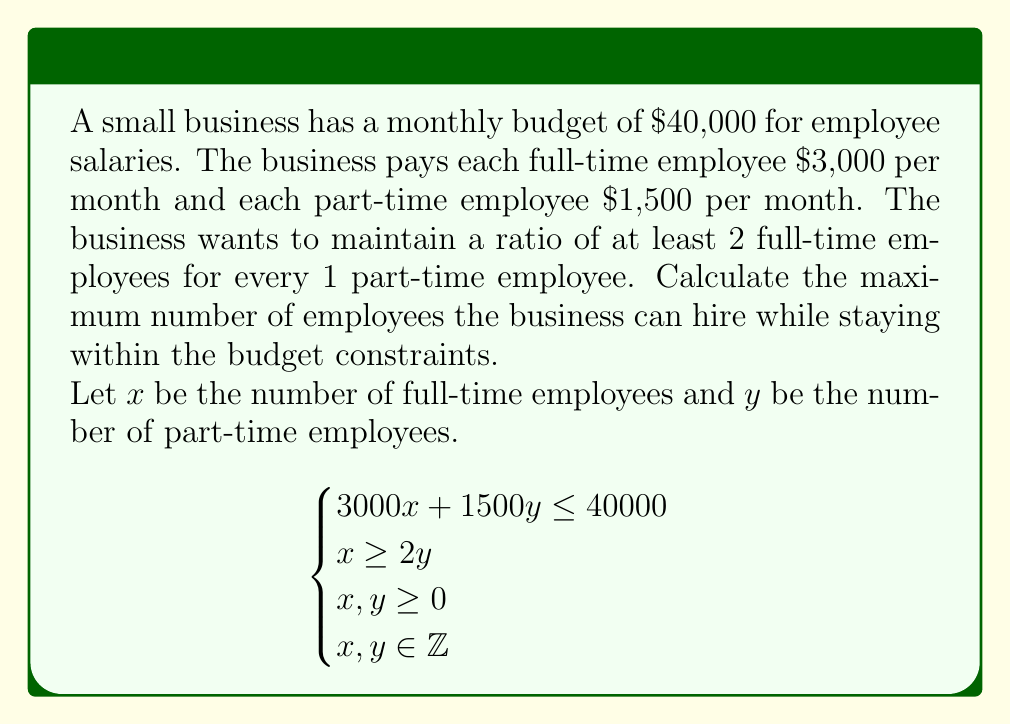Teach me how to tackle this problem. 1. Set up the inequality system:
   $$\begin{cases}
   3000x + 1500y \leq 40000 \quad \text{(budget constraint)} \\
   x \geq 2y \quad \text{(ratio constraint)} \\
   x, y \geq 0 \quad \text{(non-negative constraint)} \\
   x, y \in \mathbb{Z} \quad \text{(integer constraint)}
   \end{cases}$$

2. Simplify the budget constraint:
   $$2x + y \leq \frac{80}{3}$$

3. The objective is to maximize $x + y$ (total number of employees).

4. From the ratio constraint, we can substitute $x = 2y + z$, where $z \geq 0$.

5. Substituting into the budget constraint:
   $$2(2y + z) + y \leq \frac{80}{3}$$
   $$4y + 2z + y \leq \frac{80}{3}$$
   $$5y + 2z \leq \frac{80}{3}$$

6. To maximize $x + y = (2y + z) + y = 3y + z$, we should set $z = 0$.

7. With $z = 0$, we have:
   $$5y \leq \frac{80}{3}$$
   $$y \leq \frac{16}{3}$$

8. The maximum integer value for $y$ is 5.

9. With $y = 5$, we can calculate $x$:
   $$x = 2y = 2(5) = 10$$

10. Therefore, the maximum number of employees is $x + y = 10 + 5 = 15$.
Answer: 15 employees (10 full-time and 5 part-time) 